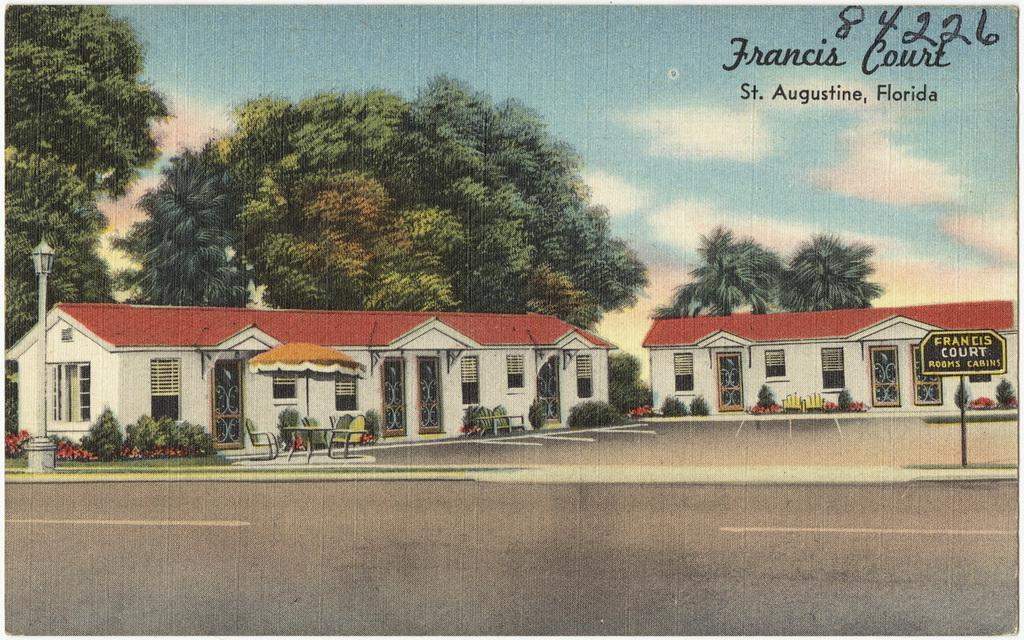What type of artwork is depicted in the image? The image appears to be a painting. Are there any numbers or letters visible in the painting? Yes, the number "84226" is written on the painting. What type of natural element can be seen in the painting? There is a tree in the painting. What type of man-made structure is present in the painting? There is a house in the painting. What type of furniture is visible in the painting? There is a chair in the painting. Can you tell me the weight of the playground in the painting? There is no playground present in the painting, so it is not possible to determine its weight. 